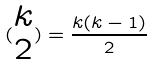<formula> <loc_0><loc_0><loc_500><loc_500>( \begin{matrix} k \\ 2 \end{matrix} ) = \frac { k ( k - 1 ) } { 2 }</formula> 